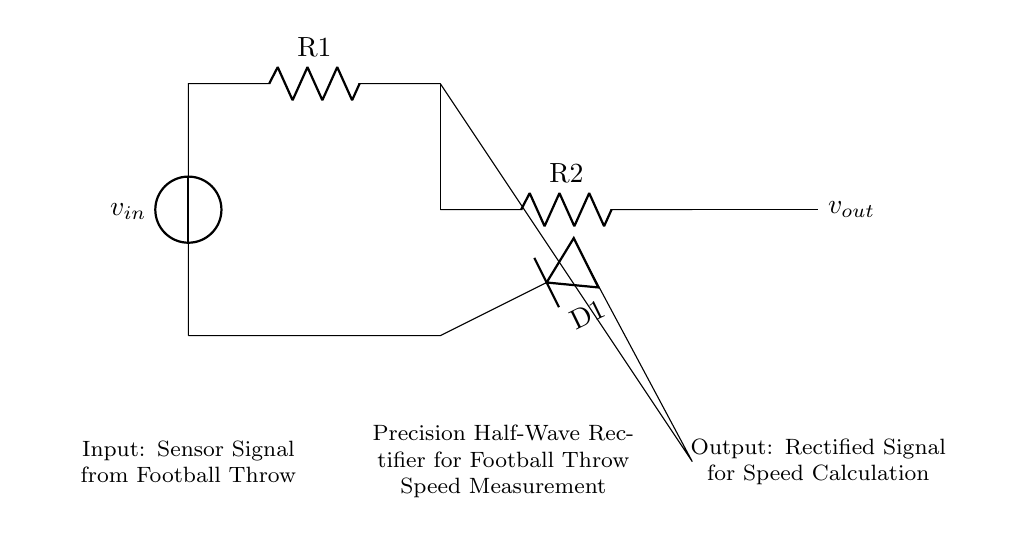What type of rectifier is shown in the circuit? The circuit is a precision half-wave rectifier, which is defined by its ability to accurately convert an AC input signal into a DC output signal, focusing on precision measurement.
Answer: precision half-wave rectifier What component is used to control the input current in the diagram? The resistor labeled R1 is used to control the input current, as it limits the amount of current that flows into the op-amp and protects it from overload.
Answer: R1 What is the role of the op-amp in this circuit? The op-amp amplifies the input signal and allows for the precise rectification process. Its configuration enables it to provide a high input impedance and low output impedance, which is essential for accurate measurements.
Answer: amplifying the input signal What type of signal is expected at the output of the circuit? The output signal, labeled as v_out, is a rectified DC signal, which indicates that the precision half-wave rectifier has converted the AC input from the sensor signal into a usable format for speed calculation.
Answer: rectified DC signal How does the diode function in this circuit? The diode, labeled D1, allows current to flow in only one direction, enabling the circuit to block the negative portion of the input AC signal, thus permitting only the positive half to pass through for rectification.
Answer: allows current in one direction What happens to the sensor signal from a football throw at the input? The sensor signal from a football throw is received as an AC signal, and this signal is then converted to a rectified output voltage that can be measured for determining the speed of the throw.
Answer: it gets rectified What is the significance of R2 in the circuit? The resistor R2 is part of the feedback loop involving the op-amp, and it helps to set the gain of the circuit, ensuring that the output voltage accurately reflects the input signal for precise measurements of throw speed.
Answer: setting the gain of the circuit 